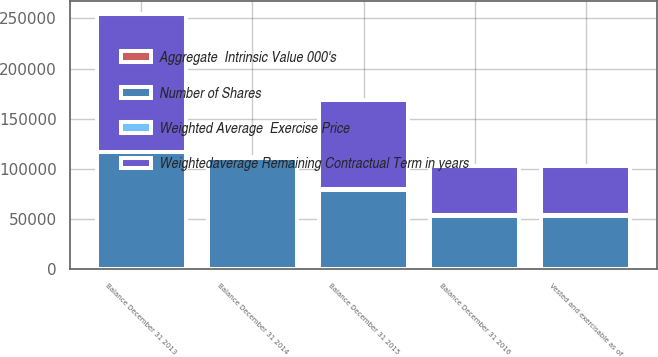Convert chart to OTSL. <chart><loc_0><loc_0><loc_500><loc_500><stacked_bar_chart><ecel><fcel>Balance December 31 2013<fcel>Balance December 31 2014<fcel>Balance December 31 2015<fcel>Balance December 31 2016<fcel>Vested and exercisable as of<nl><fcel>Weightedaverage Remaining Contractual Term in years<fcel>137708<fcel>383.03<fcel>89104<fcel>48983<fcel>48931<nl><fcel>Weighted Average  Exercise Price<fcel>315.36<fcel>380.05<fcel>383.03<fcel>372.07<fcel>372.11<nl><fcel>Number of Shares<fcel>116686<fcel>111277<fcel>79474<fcel>53587<fcel>53528<nl><fcel>Aggregate  Intrinsic Value 000's<fcel>6.6<fcel>6.5<fcel>5.4<fcel>4.4<fcel>4.4<nl></chart> 